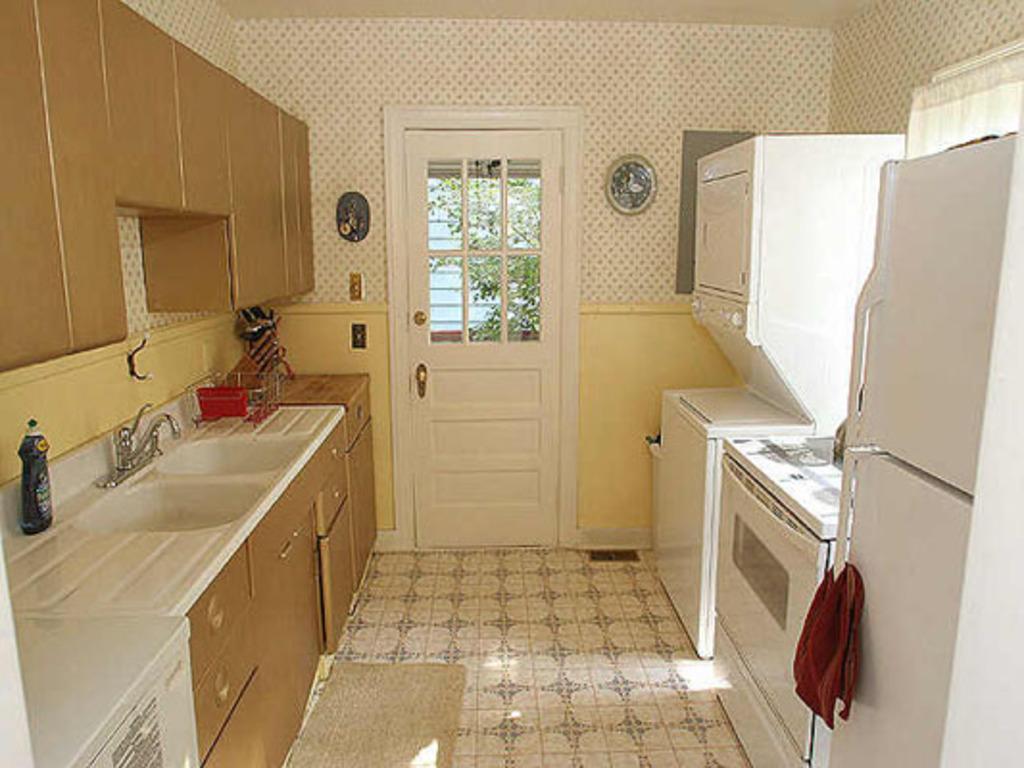Please provide a concise description of this image. In this picture I can see the kitchen platform. On the left I can see the wash basin, water taps, knives holder and other objects. In the top left I can see the cupboards. In the center there is a door, beside that I can see the wall clock. On the right I can see the washing machine, fridge and other objects. 